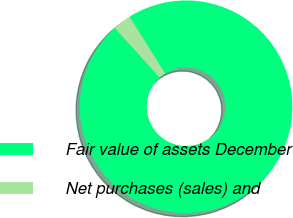Convert chart to OTSL. <chart><loc_0><loc_0><loc_500><loc_500><pie_chart><fcel>Fair value of assets December<fcel>Net purchases (sales) and<nl><fcel>97.2%<fcel>2.8%<nl></chart> 